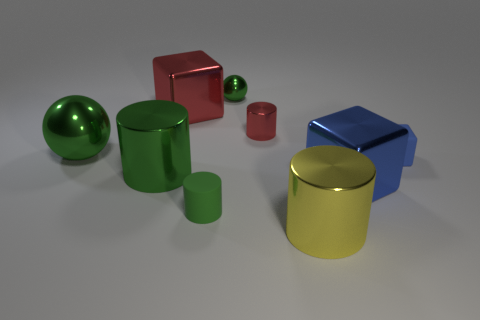Subtract 1 spheres. How many spheres are left? 1 Subtract all gray cylinders. Subtract all cyan cubes. How many cylinders are left? 4 Subtract all yellow cylinders. How many cyan balls are left? 0 Subtract all gray blocks. Subtract all red cylinders. How many objects are left? 8 Add 2 green shiny objects. How many green shiny objects are left? 5 Add 2 small metallic cubes. How many small metallic cubes exist? 2 Subtract all blue cubes. How many cubes are left? 1 Subtract all red cylinders. How many cylinders are left? 3 Subtract 0 cyan balls. How many objects are left? 9 Subtract all balls. How many objects are left? 7 